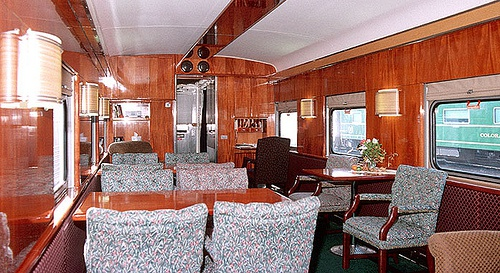Describe the objects in this image and their specific colors. I can see chair in salmon, lavender, darkgray, and gray tones, chair in salmon, lavender, darkgray, and gray tones, chair in salmon, darkgray, gray, black, and maroon tones, dining table in salmon and brown tones, and chair in salmon, brown, maroon, and tan tones in this image. 